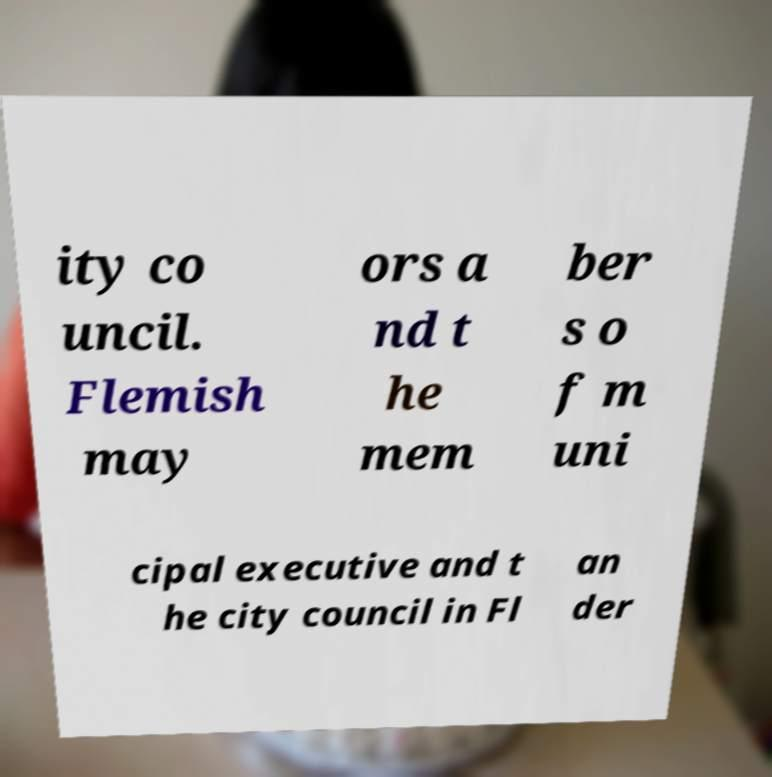I need the written content from this picture converted into text. Can you do that? ity co uncil. Flemish may ors a nd t he mem ber s o f m uni cipal executive and t he city council in Fl an der 